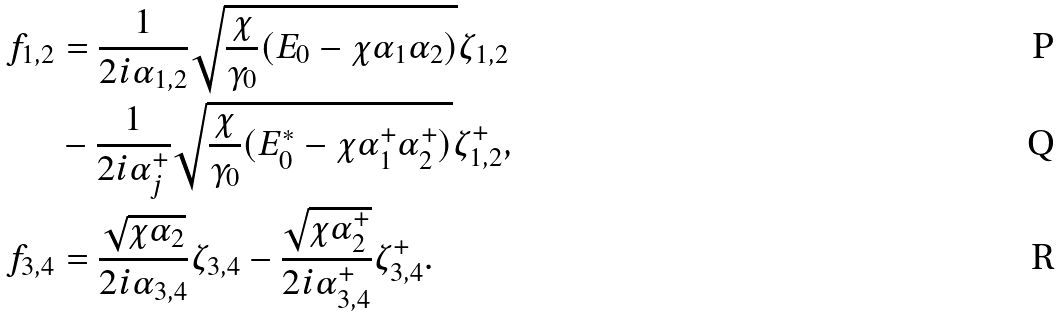Convert formula to latex. <formula><loc_0><loc_0><loc_500><loc_500>f _ { 1 , 2 } & = \frac { 1 } { 2 i \alpha _ { 1 , 2 } } \sqrt { \frac { \chi } { \gamma _ { 0 } } ( E _ { 0 } - \chi \alpha _ { 1 } \alpha _ { 2 } ) } \zeta _ { 1 , 2 } \\ & - \frac { 1 } { 2 i \alpha _ { j } ^ { + } } \sqrt { \frac { \chi } { \gamma _ { 0 } } ( E _ { 0 } ^ { \ast } - \chi \alpha _ { 1 } ^ { + } \alpha _ { 2 } ^ { + } ) } \zeta _ { 1 , 2 } ^ { + } , \\ f _ { 3 , 4 } & = \frac { \sqrt { \chi \alpha _ { 2 } } } { 2 i \alpha _ { 3 , 4 } } \zeta _ { 3 , 4 } - \frac { \sqrt { \chi \alpha _ { 2 } ^ { + } } } { 2 i \alpha _ { 3 , 4 } ^ { + } } \zeta _ { 3 , 4 } ^ { + } .</formula> 